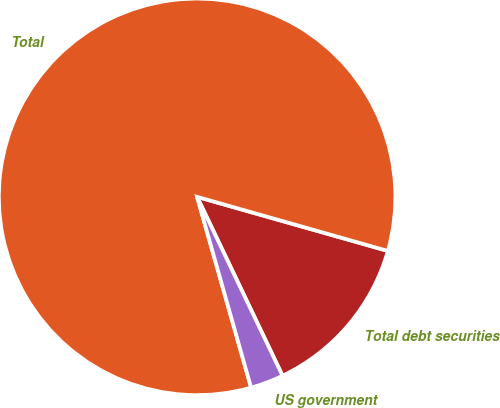<chart> <loc_0><loc_0><loc_500><loc_500><pie_chart><fcel>Total debt securities<fcel>Total<fcel>US government<nl><fcel>13.51%<fcel>83.78%<fcel>2.7%<nl></chart> 